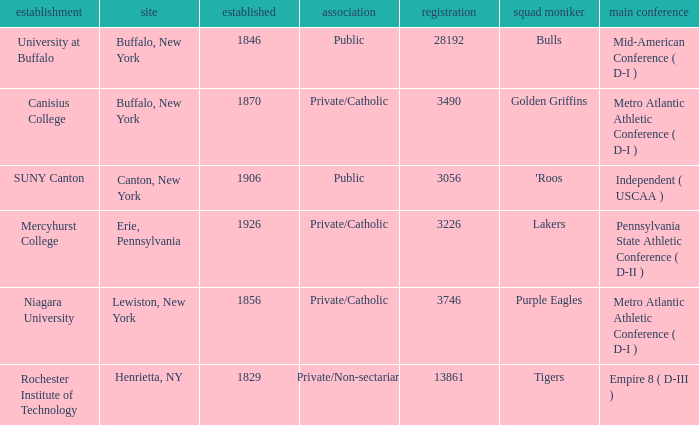What affiliation is Erie, Pennsylvania? Private/Catholic. 